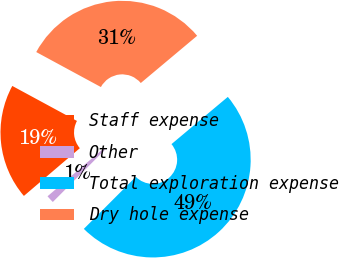Convert chart to OTSL. <chart><loc_0><loc_0><loc_500><loc_500><pie_chart><fcel>Staff expense<fcel>Other<fcel>Total exploration expense<fcel>Dry hole expense<nl><fcel>19.14%<fcel>1.27%<fcel>48.59%<fcel>31.0%<nl></chart> 